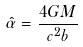Convert formula to latex. <formula><loc_0><loc_0><loc_500><loc_500>\hat { \alpha } = \frac { 4 G M } { c ^ { 2 } b }</formula> 